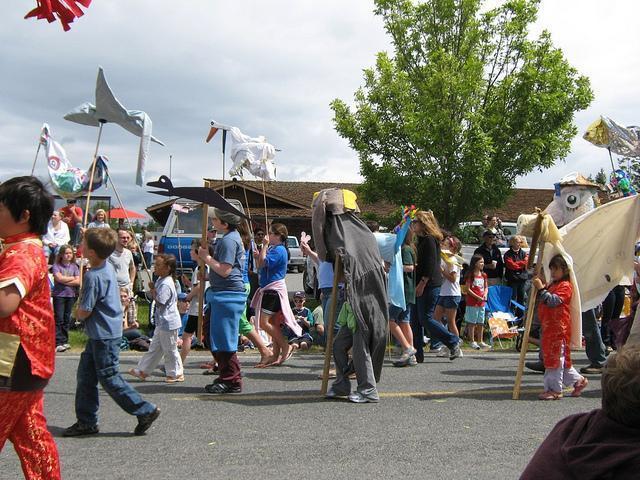How many trees are in this scene?
Give a very brief answer. 1. How many people are visible?
Give a very brief answer. 9. How many dogs are wearing a leash?
Give a very brief answer. 0. 